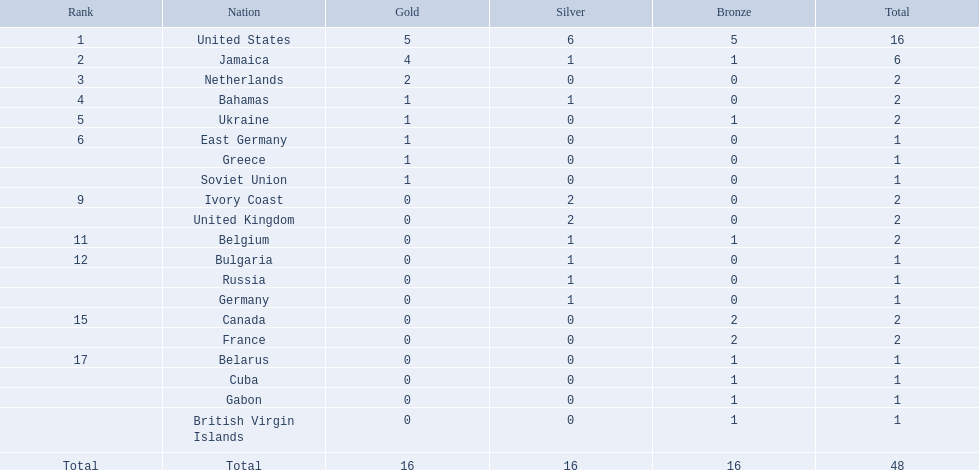What was the greatest quantity of medals earned by any country? 16. Which country secured that many medals? United States. Which territories participated? United States, Jamaica, Netherlands, Bahamas, Ukraine, East Germany, Greece, Soviet Union, Ivory Coast, United Kingdom, Belgium, Bulgaria, Russia, Germany, Canada, France, Belarus, Cuba, Gabon, British Virgin Islands. Can you give me this table as a dict? {'header': ['Rank', 'Nation', 'Gold', 'Silver', 'Bronze', 'Total'], 'rows': [['1', 'United States', '5', '6', '5', '16'], ['2', 'Jamaica', '4', '1', '1', '6'], ['3', 'Netherlands', '2', '0', '0', '2'], ['4', 'Bahamas', '1', '1', '0', '2'], ['5', 'Ukraine', '1', '0', '1', '2'], ['6', 'East Germany', '1', '0', '0', '1'], ['', 'Greece', '1', '0', '0', '1'], ['', 'Soviet Union', '1', '0', '0', '1'], ['9', 'Ivory Coast', '0', '2', '0', '2'], ['', 'United Kingdom', '0', '2', '0', '2'], ['11', 'Belgium', '0', '1', '1', '2'], ['12', 'Bulgaria', '0', '1', '0', '1'], ['', 'Russia', '0', '1', '0', '1'], ['', 'Germany', '0', '1', '0', '1'], ['15', 'Canada', '0', '0', '2', '2'], ['', 'France', '0', '0', '2', '2'], ['17', 'Belarus', '0', '0', '1', '1'], ['', 'Cuba', '0', '0', '1', '1'], ['', 'Gabon', '0', '0', '1', '1'], ['', 'British Virgin Islands', '0', '0', '1', '1'], ['Total', 'Total', '16', '16', '16', '48']]} How many golden medals were acquired by each? 5, 4, 2, 1, 1, 1, 1, 1, 0, 0, 0, 0, 0, 0, 0, 0, 0, 0, 0, 0. And which territory claimed the most? United States. Could you help me parse every detail presented in this table? {'header': ['Rank', 'Nation', 'Gold', 'Silver', 'Bronze', 'Total'], 'rows': [['1', 'United States', '5', '6', '5', '16'], ['2', 'Jamaica', '4', '1', '1', '6'], ['3', 'Netherlands', '2', '0', '0', '2'], ['4', 'Bahamas', '1', '1', '0', '2'], ['5', 'Ukraine', '1', '0', '1', '2'], ['6', 'East Germany', '1', '0', '0', '1'], ['', 'Greece', '1', '0', '0', '1'], ['', 'Soviet Union', '1', '0', '0', '1'], ['9', 'Ivory Coast', '0', '2', '0', '2'], ['', 'United Kingdom', '0', '2', '0', '2'], ['11', 'Belgium', '0', '1', '1', '2'], ['12', 'Bulgaria', '0', '1', '0', '1'], ['', 'Russia', '0', '1', '0', '1'], ['', 'Germany', '0', '1', '0', '1'], ['15', 'Canada', '0', '0', '2', '2'], ['', 'France', '0', '0', '2', '2'], ['17', 'Belarus', '0', '0', '1', '1'], ['', 'Cuba', '0', '0', '1', '1'], ['', 'Gabon', '0', '0', '1', '1'], ['', 'British Virgin Islands', '0', '0', '1', '1'], ['Total', 'Total', '16', '16', '16', '48']]} Which country had the largest number of medals? United States. How many medals did the us achieve? 16. What was the highest medal count for a country (beyond 16)? 6. Which nation managed to secure 6 medals? Jamaica. 